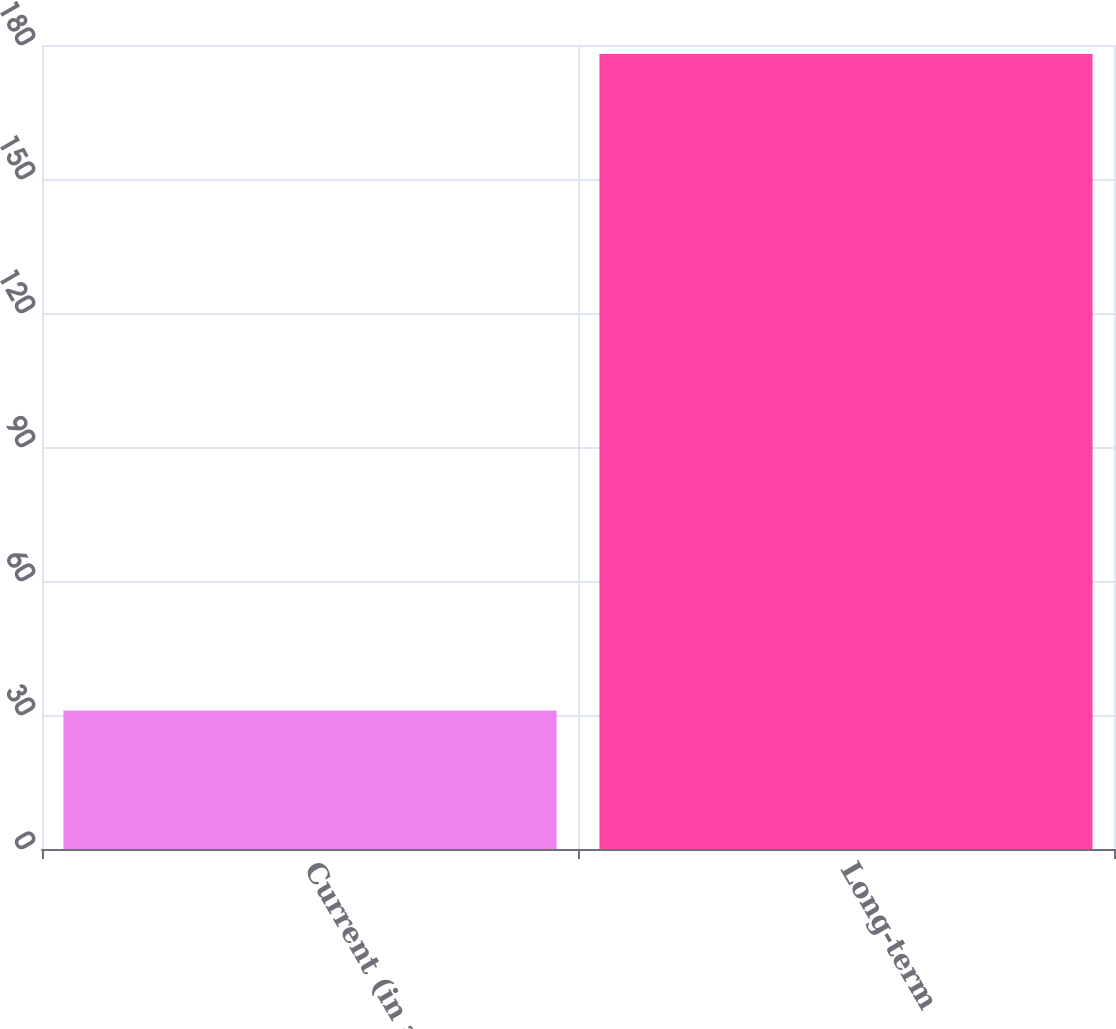<chart> <loc_0><loc_0><loc_500><loc_500><bar_chart><fcel>Current (in accrued<fcel>Long-term<nl><fcel>31<fcel>178<nl></chart> 